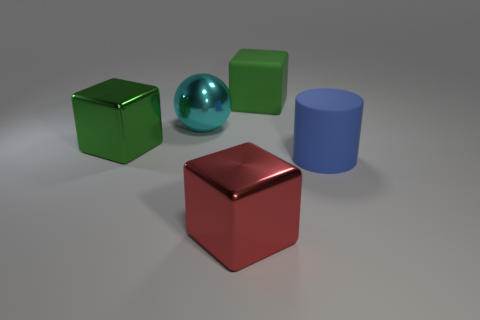Can you tell me how many green objects are in this image? Certainly, there is one green object in the image. It is a green cube with a reflective surface placed on the left side of the image.  Which object is the largest in the image? The largest object in the image appears to be the red cube. Its size is more prominent in comparison to the other objects, which include a smaller green cube, a smaller blue cylinder, and a still smaller shiny sphere. 